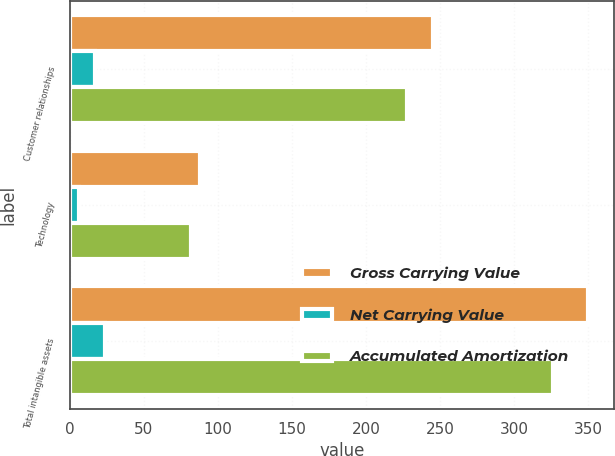<chart> <loc_0><loc_0><loc_500><loc_500><stacked_bar_chart><ecel><fcel>Customer relationships<fcel>Technology<fcel>Total intangible assets<nl><fcel>Gross Carrying Value<fcel>245<fcel>88<fcel>350<nl><fcel>Net Carrying Value<fcel>17<fcel>6<fcel>24<nl><fcel>Accumulated Amortization<fcel>228<fcel>82<fcel>326<nl></chart> 